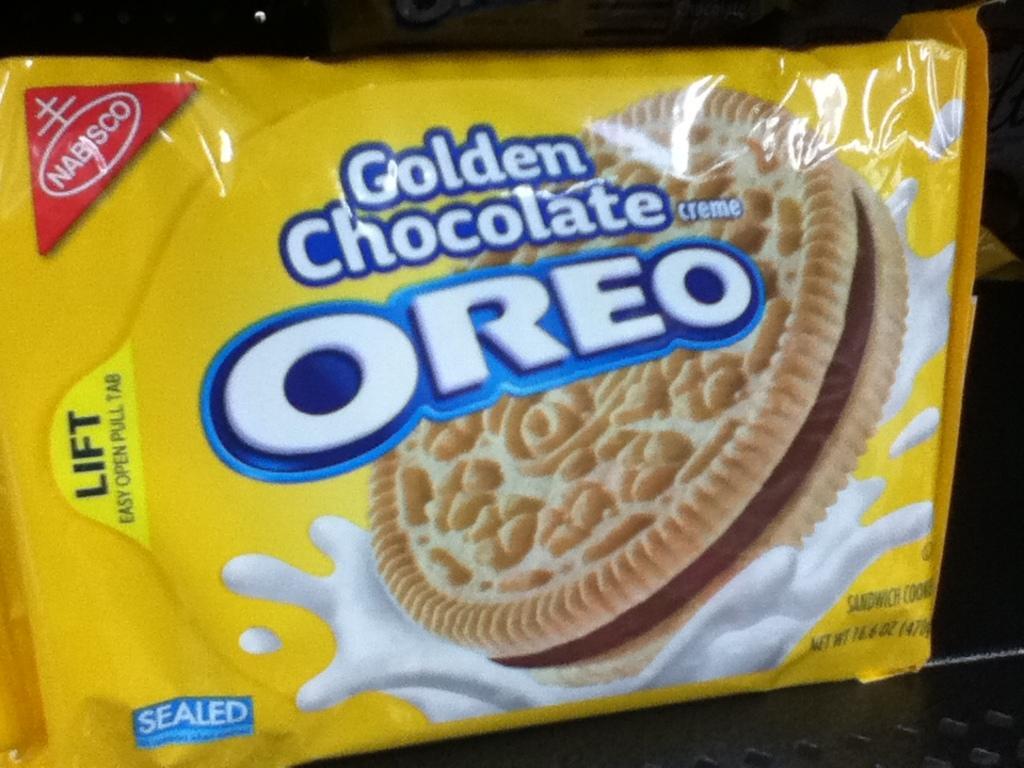Can you describe this image briefly? In this image there is a yellow color OREO biscuit packet on the object. 